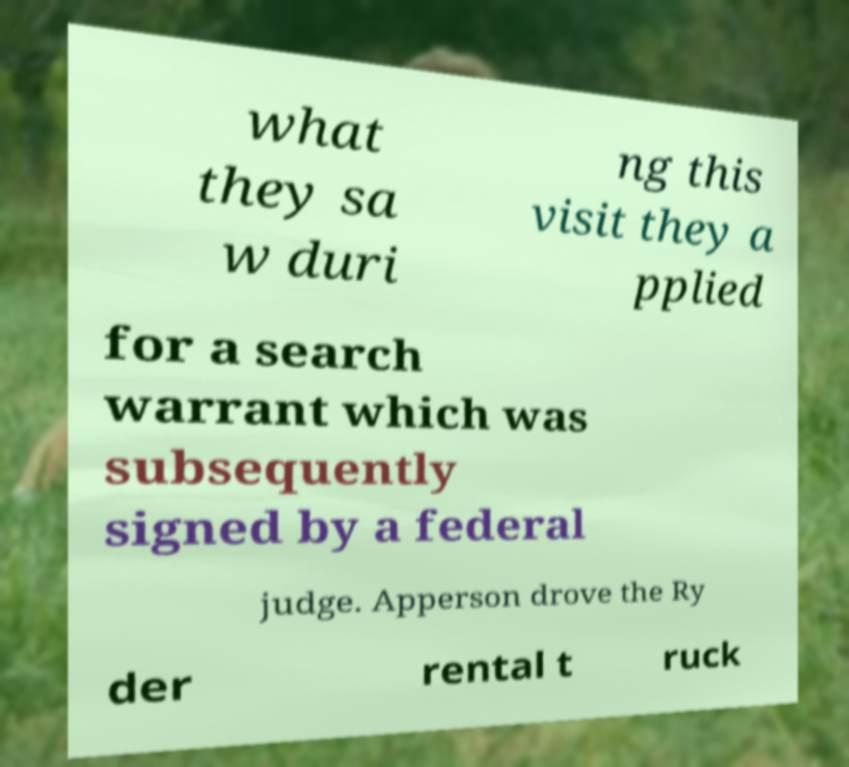I need the written content from this picture converted into text. Can you do that? what they sa w duri ng this visit they a pplied for a search warrant which was subsequently signed by a federal judge. Apperson drove the Ry der rental t ruck 